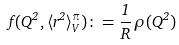Convert formula to latex. <formula><loc_0><loc_0><loc_500><loc_500>f ( Q ^ { 2 } , \langle r ^ { 2 } \rangle _ { V } ^ { \pi } ) \colon = \frac { 1 } { R } \, \rho ( Q ^ { 2 } )</formula> 